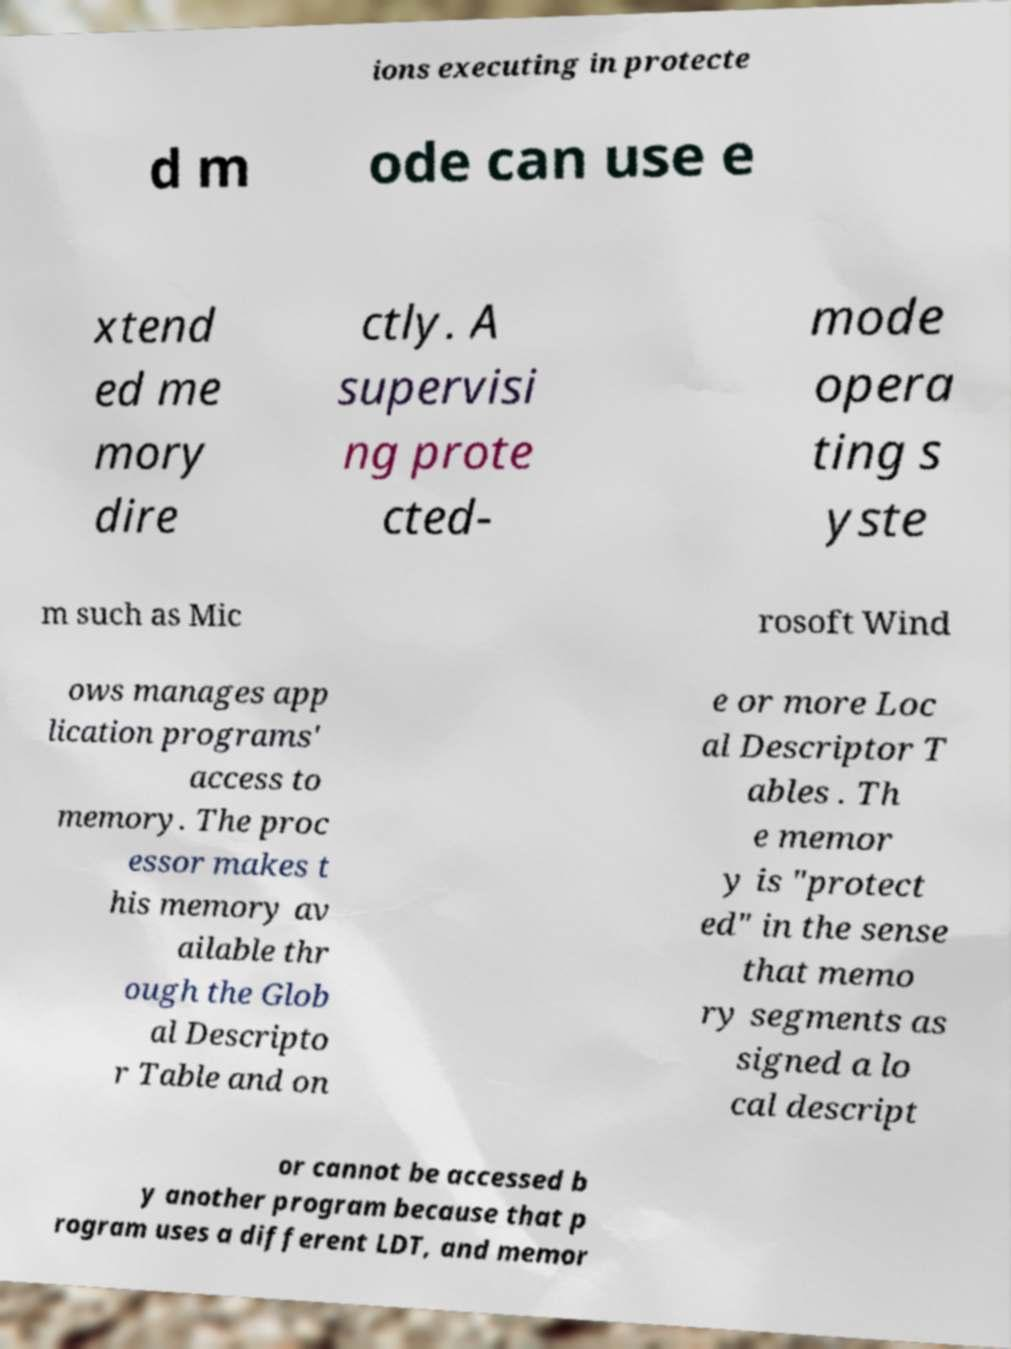Can you accurately transcribe the text from the provided image for me? ions executing in protecte d m ode can use e xtend ed me mory dire ctly. A supervisi ng prote cted- mode opera ting s yste m such as Mic rosoft Wind ows manages app lication programs' access to memory. The proc essor makes t his memory av ailable thr ough the Glob al Descripto r Table and on e or more Loc al Descriptor T ables . Th e memor y is "protect ed" in the sense that memo ry segments as signed a lo cal descript or cannot be accessed b y another program because that p rogram uses a different LDT, and memor 